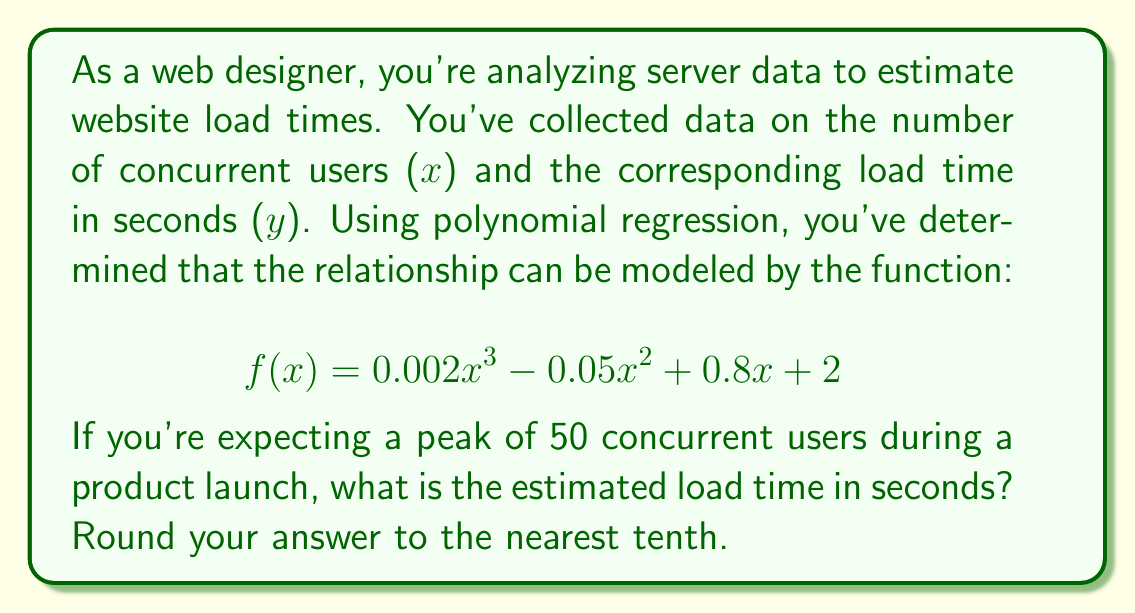Can you answer this question? To solve this problem, we need to follow these steps:

1. Identify the given function:
   $$ f(x) = 0.002x^3 - 0.05x^2 + 0.8x + 2 $$

2. Substitute x = 50 into the function:
   $$ f(50) = 0.002(50)^3 - 0.05(50)^2 + 0.8(50) + 2 $$

3. Calculate each term:
   - $0.002(50)^3 = 0.002 \times 125000 = 250$
   - $-0.05(50)^2 = -0.05 \times 2500 = -125$
   - $0.8(50) = 40$
   - The constant term is 2

4. Sum up all the terms:
   $$ f(50) = 250 - 125 + 40 + 2 = 167 $$

5. Round the result to the nearest tenth:
   167 rounds to 167.0 seconds

This polynomial model suggests that with 50 concurrent users, the estimated load time would be 167.0 seconds.
Answer: 167.0 seconds 